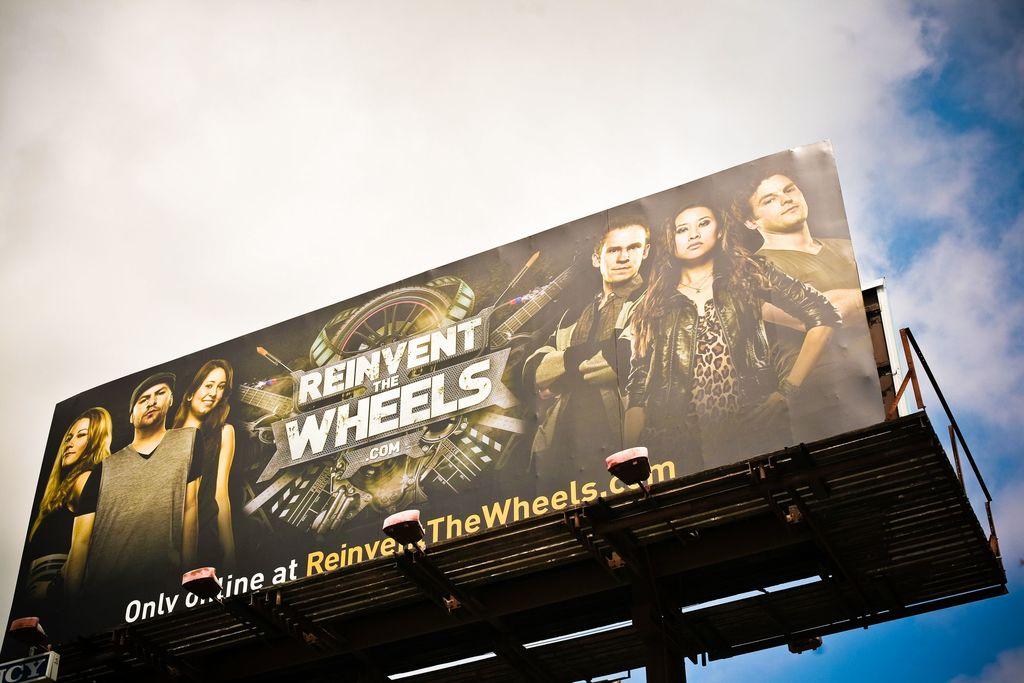What is going to be reinvented?
Your answer should be compact. Wheels. Can you buy what is advertised in a store or only online?
Offer a very short reply. Only online. 